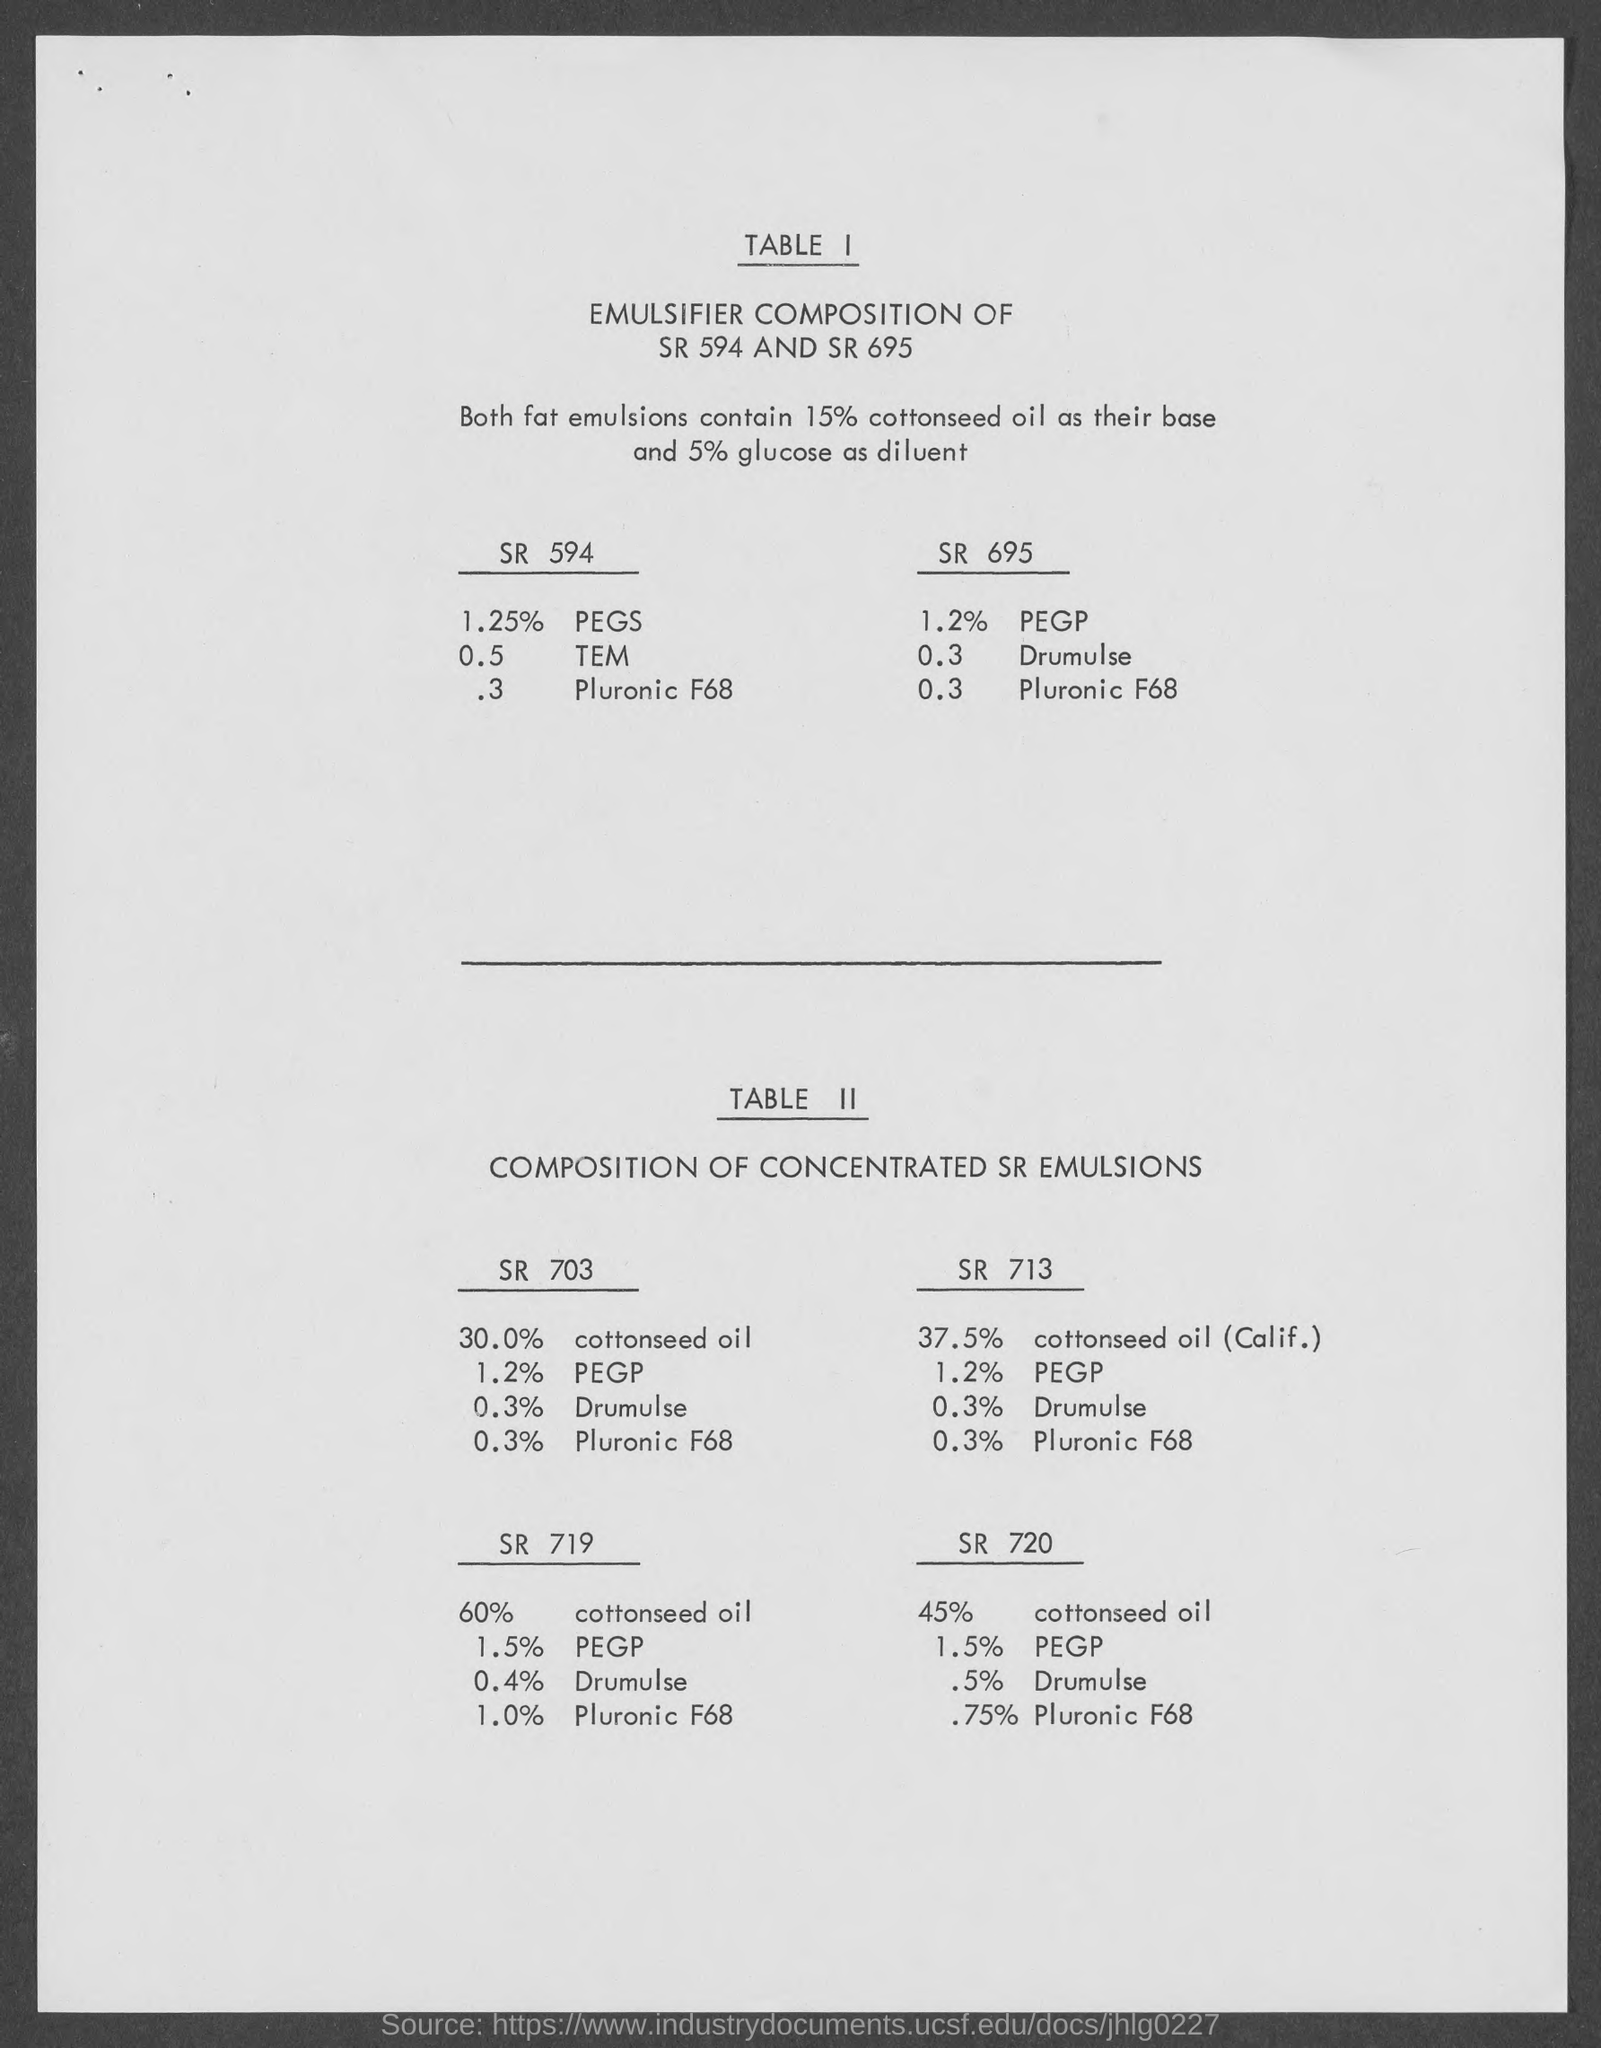What is the title of table II ?
Make the answer very short. Composition of concentrated SR emulsions. What is the title of table I?
Your answer should be very brief. Emulsifier composition of SR 594 and SR 695. 